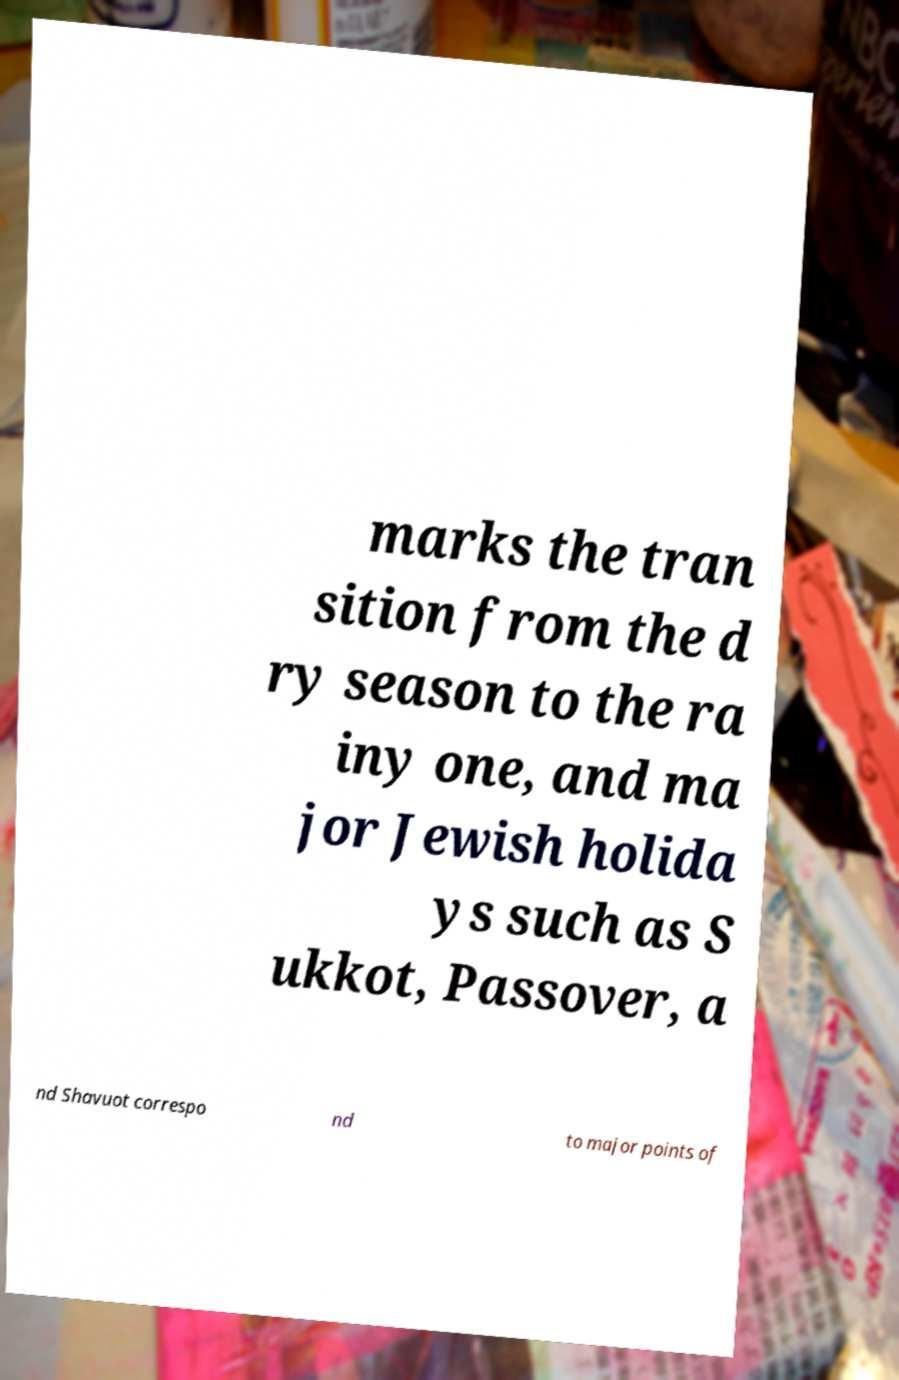Please identify and transcribe the text found in this image. marks the tran sition from the d ry season to the ra iny one, and ma jor Jewish holida ys such as S ukkot, Passover, a nd Shavuot correspo nd to major points of 